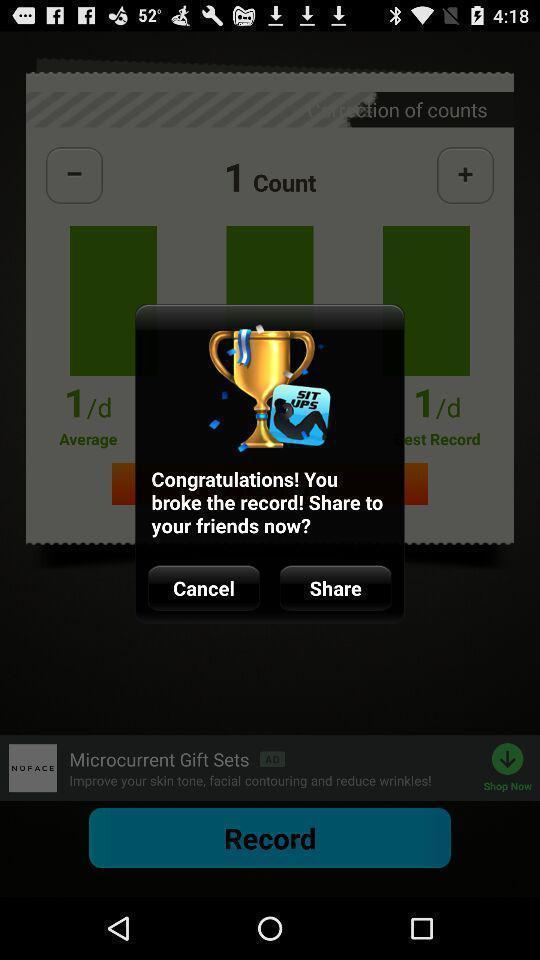Please provide a description for this image. Pop-up showing a notification. 